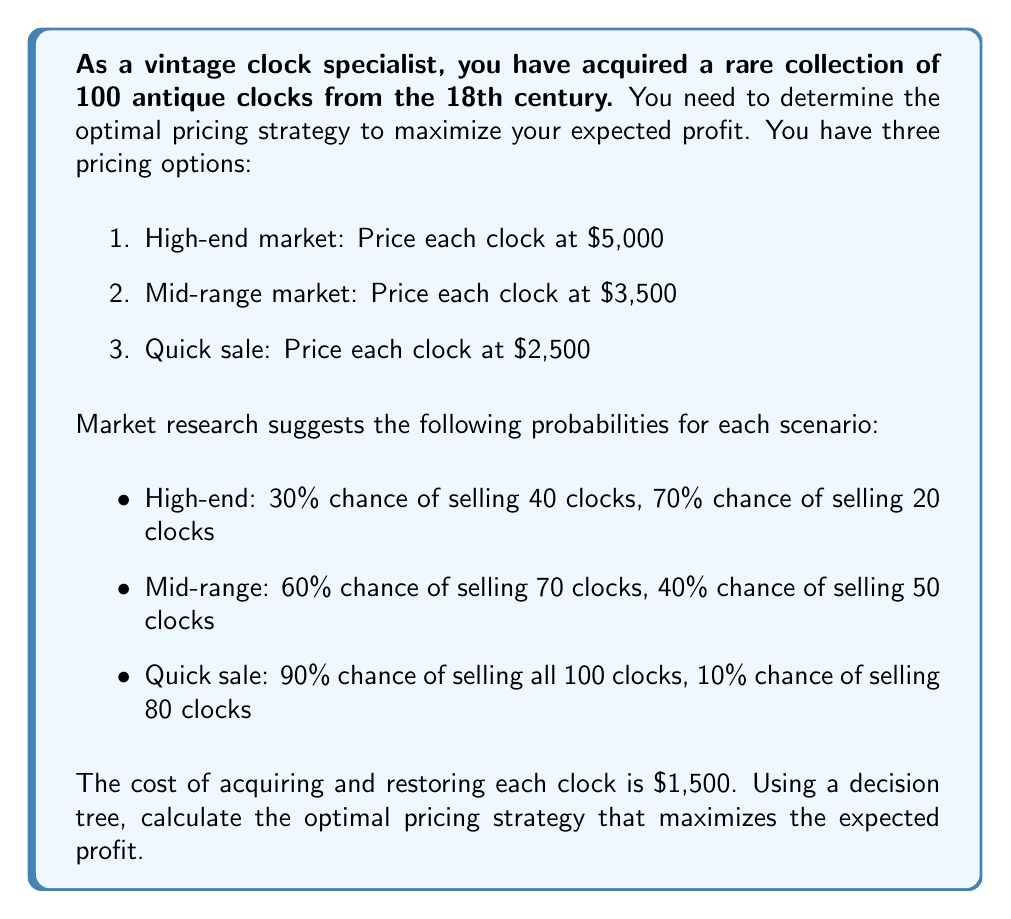What is the answer to this math problem? To solve this problem, we'll construct a decision tree and calculate the expected profit for each pricing strategy.

1. High-end market ($5,000 per clock):
   - Probability of selling 40 clocks: 0.3
   - Probability of selling 20 clocks: 0.7
   
   Expected profit:
   $$E(\text{High-end}) = 0.3 \times (40 \times (5000 - 1500)) + 0.7 \times (20 \times (5000 - 1500))$$
   $$E(\text{High-end}) = 0.3 \times (40 \times 3500) + 0.7 \times (20 \times 3500)$$
   $$E(\text{High-end}) = 0.3 \times 140,000 + 0.7 \times 70,000$$
   $$E(\text{High-end}) = 42,000 + 49,000 = 91,000$$

2. Mid-range market ($3,500 per clock):
   - Probability of selling 70 clocks: 0.6
   - Probability of selling 50 clocks: 0.4
   
   Expected profit:
   $$E(\text{Mid-range}) = 0.6 \times (70 \times (3500 - 1500)) + 0.4 \times (50 \times (3500 - 1500))$$
   $$E(\text{Mid-range}) = 0.6 \times (70 \times 2000) + 0.4 \times (50 \times 2000)$$
   $$E(\text{Mid-range}) = 0.6 \times 140,000 + 0.4 \times 100,000$$
   $$E(\text{Mid-range}) = 84,000 + 40,000 = 124,000$$

3. Quick sale ($2,500 per clock):
   - Probability of selling 100 clocks: 0.9
   - Probability of selling 80 clocks: 0.1
   
   Expected profit:
   $$E(\text{Quick sale}) = 0.9 \times (100 \times (2500 - 1500)) + 0.1 \times (80 \times (2500 - 1500))$$
   $$E(\text{Quick sale}) = 0.9 \times (100 \times 1000) + 0.1 \times (80 \times 1000)$$
   $$E(\text{Quick sale}) = 0.9 \times 100,000 + 0.1 \times 80,000$$
   $$E(\text{Quick sale}) = 90,000 + 8,000 = 98,000$$

Comparing the expected profits:
1. High-end market: $91,000
2. Mid-range market: $124,000
3. Quick sale: $98,000

The optimal pricing strategy is the one that maximizes the expected profit, which is the mid-range market strategy.
Answer: The optimal pricing strategy is to price each clock at $3,500 (mid-range market), which yields an expected profit of $124,000. 